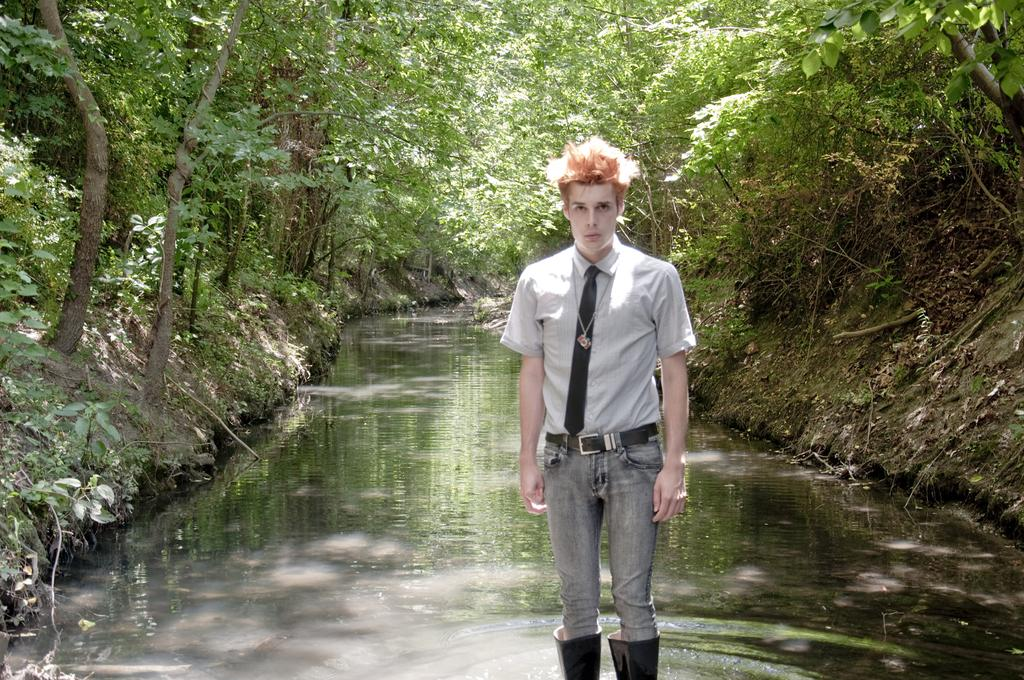What is the person in the image doing? The person is standing in the water. What can be seen in the background of the image? There are trees visible in the background of the image. What songs is the person singing in the image? There is no indication in the image that the person is singing any songs. 